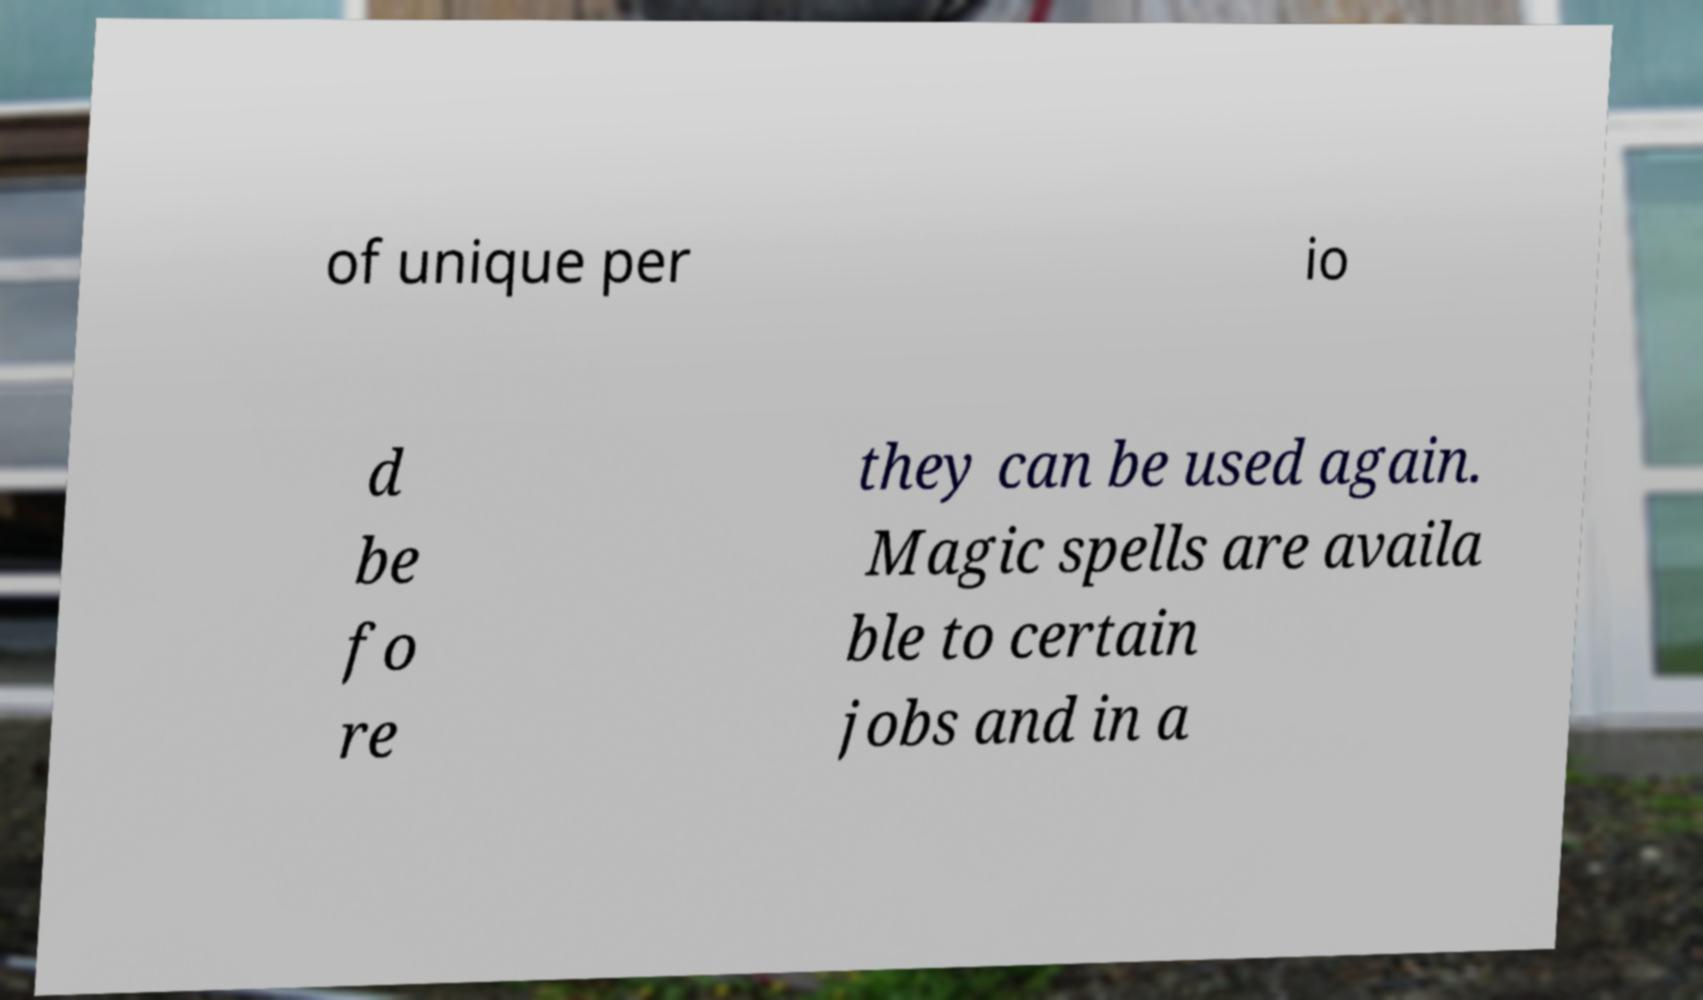What messages or text are displayed in this image? I need them in a readable, typed format. of unique per io d be fo re they can be used again. Magic spells are availa ble to certain jobs and in a 